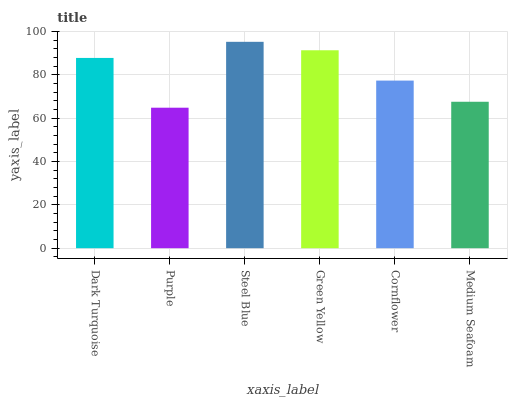Is Purple the minimum?
Answer yes or no. Yes. Is Steel Blue the maximum?
Answer yes or no. Yes. Is Steel Blue the minimum?
Answer yes or no. No. Is Purple the maximum?
Answer yes or no. No. Is Steel Blue greater than Purple?
Answer yes or no. Yes. Is Purple less than Steel Blue?
Answer yes or no. Yes. Is Purple greater than Steel Blue?
Answer yes or no. No. Is Steel Blue less than Purple?
Answer yes or no. No. Is Dark Turquoise the high median?
Answer yes or no. Yes. Is Cornflower the low median?
Answer yes or no. Yes. Is Purple the high median?
Answer yes or no. No. Is Green Yellow the low median?
Answer yes or no. No. 